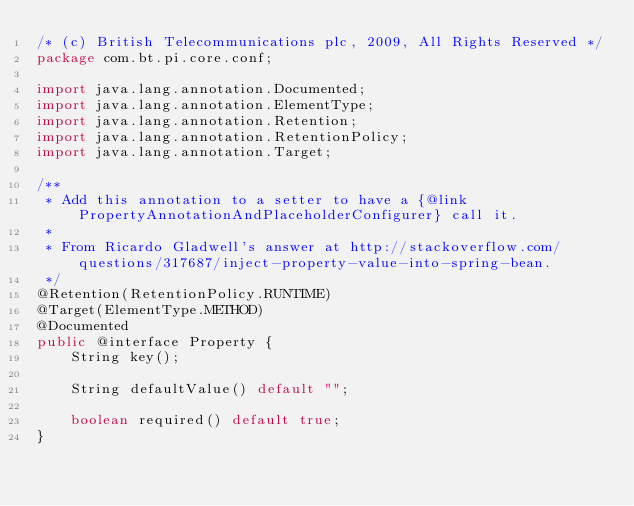Convert code to text. <code><loc_0><loc_0><loc_500><loc_500><_Java_>/* (c) British Telecommunications plc, 2009, All Rights Reserved */
package com.bt.pi.core.conf;

import java.lang.annotation.Documented;
import java.lang.annotation.ElementType;
import java.lang.annotation.Retention;
import java.lang.annotation.RetentionPolicy;
import java.lang.annotation.Target;

/**
 * Add this annotation to a setter to have a {@link PropertyAnnotationAndPlaceholderConfigurer} call it.
 * 
 * From Ricardo Gladwell's answer at http://stackoverflow.com/questions/317687/inject-property-value-into-spring-bean.
 */
@Retention(RetentionPolicy.RUNTIME)
@Target(ElementType.METHOD)
@Documented
public @interface Property {
    String key();

    String defaultValue() default "";

    boolean required() default true;
}
</code> 